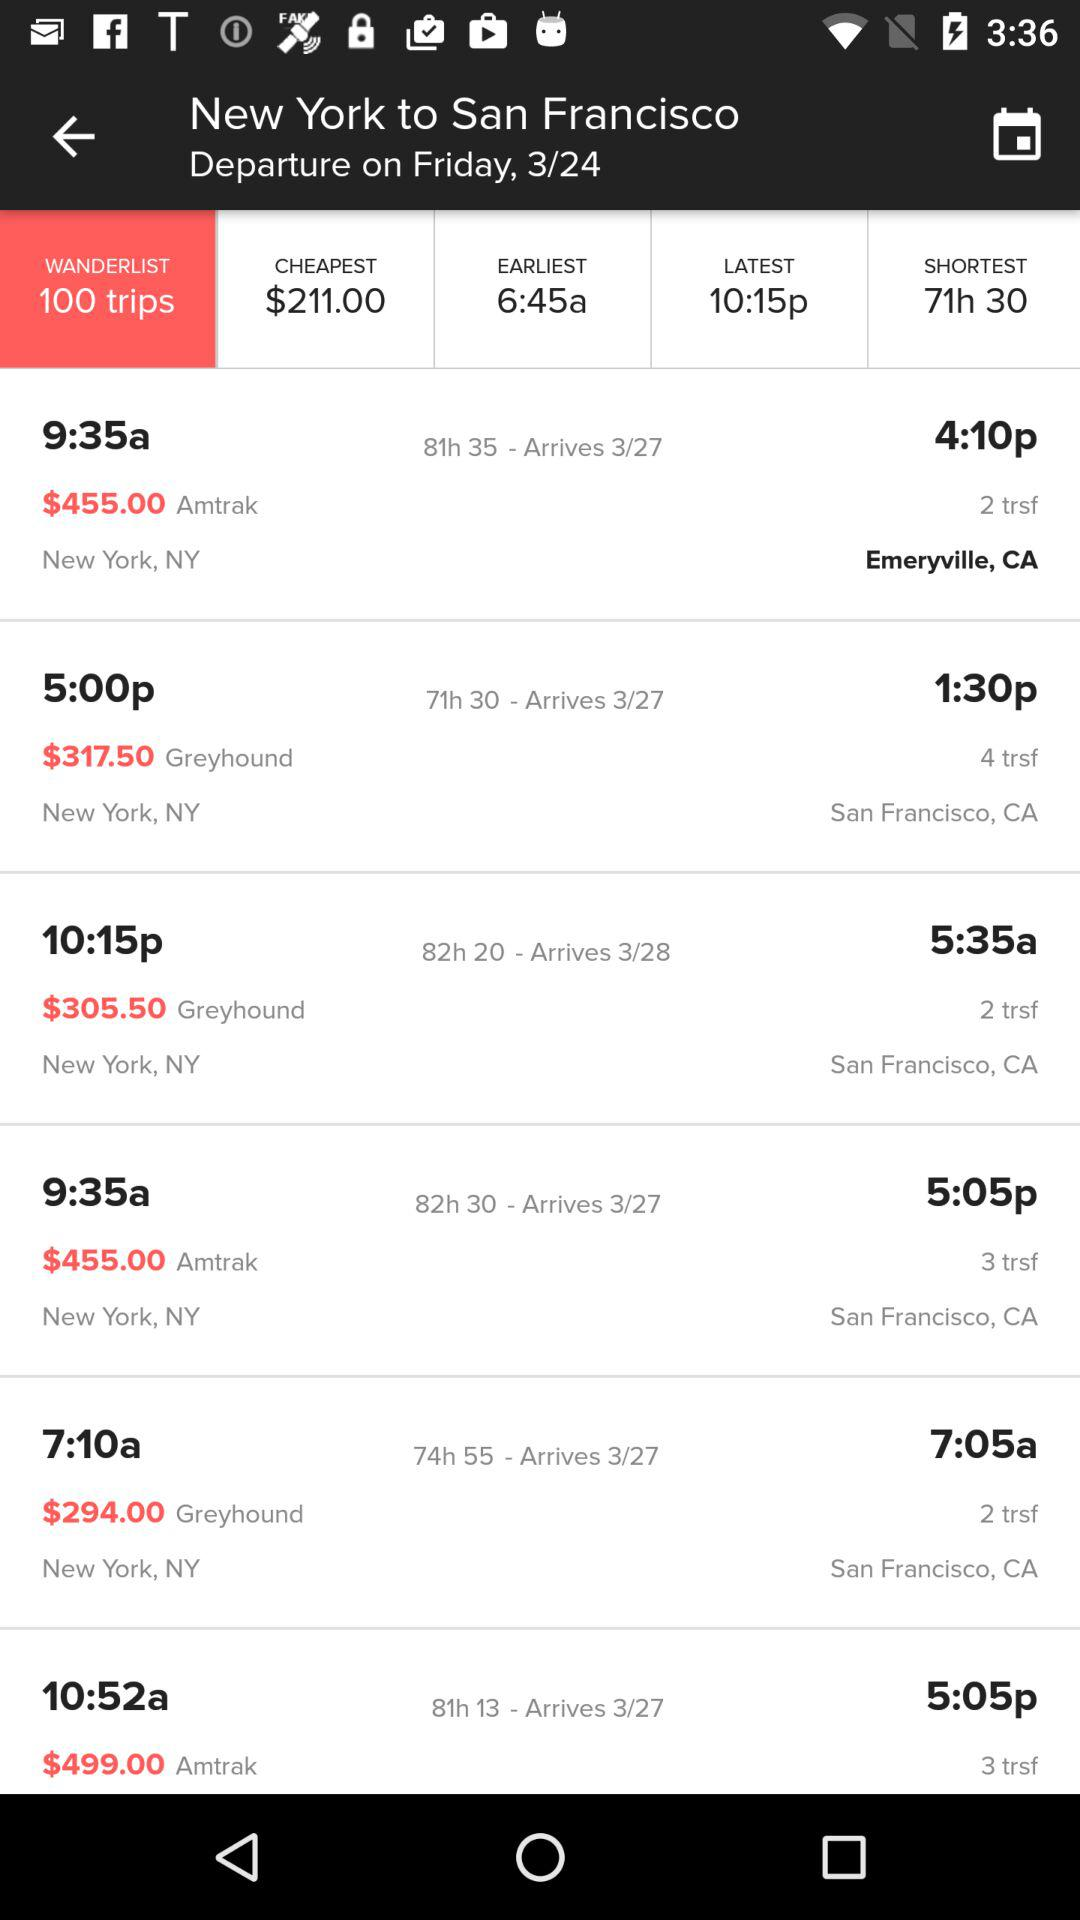How many trips are there? There are 100 trips. 